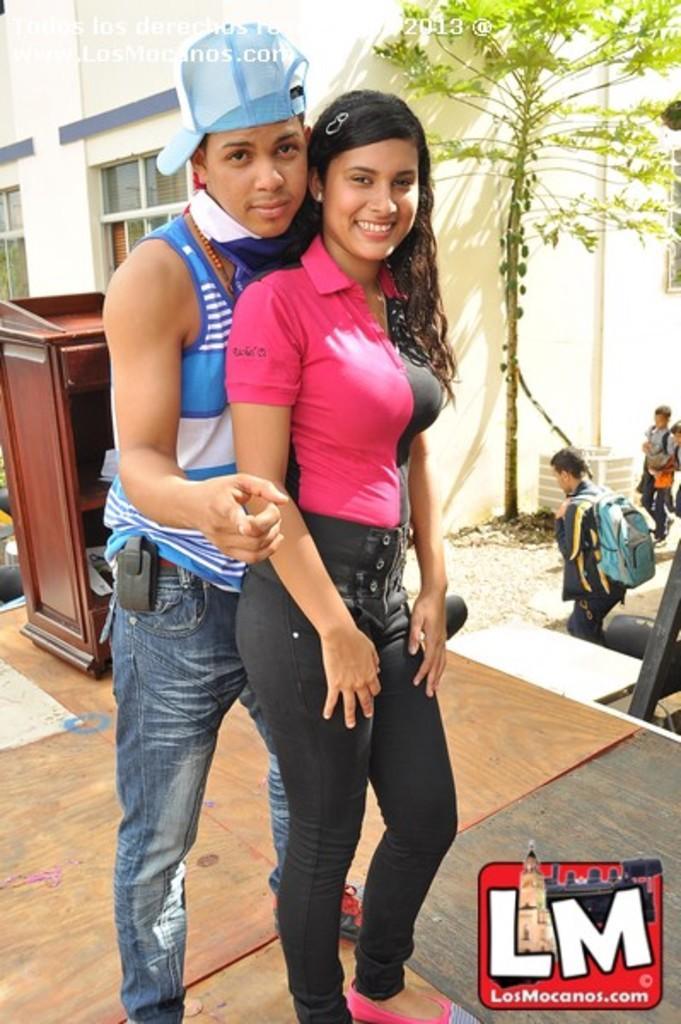Could you give a brief overview of what you see in this image? In the image I can see a lady and a guy who is wearing the hat and around there are some trees, building, people and a desk. 